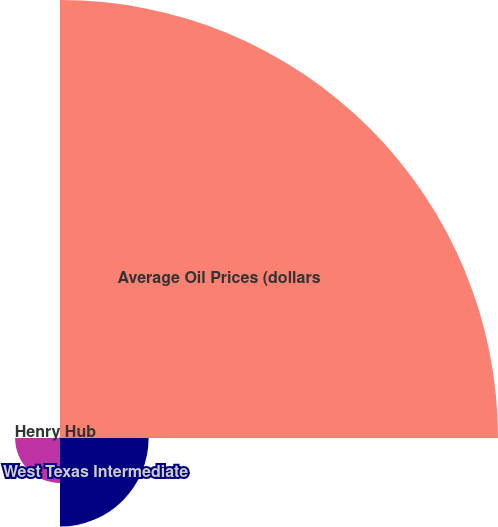<chart> <loc_0><loc_0><loc_500><loc_500><pie_chart><fcel>Average Oil Prices (dollars<fcel>West Texas Intermediate<fcel>United Kingdom Brent<fcel>Henry Hub<nl><fcel>76.48%<fcel>15.47%<fcel>7.84%<fcel>0.21%<nl></chart> 